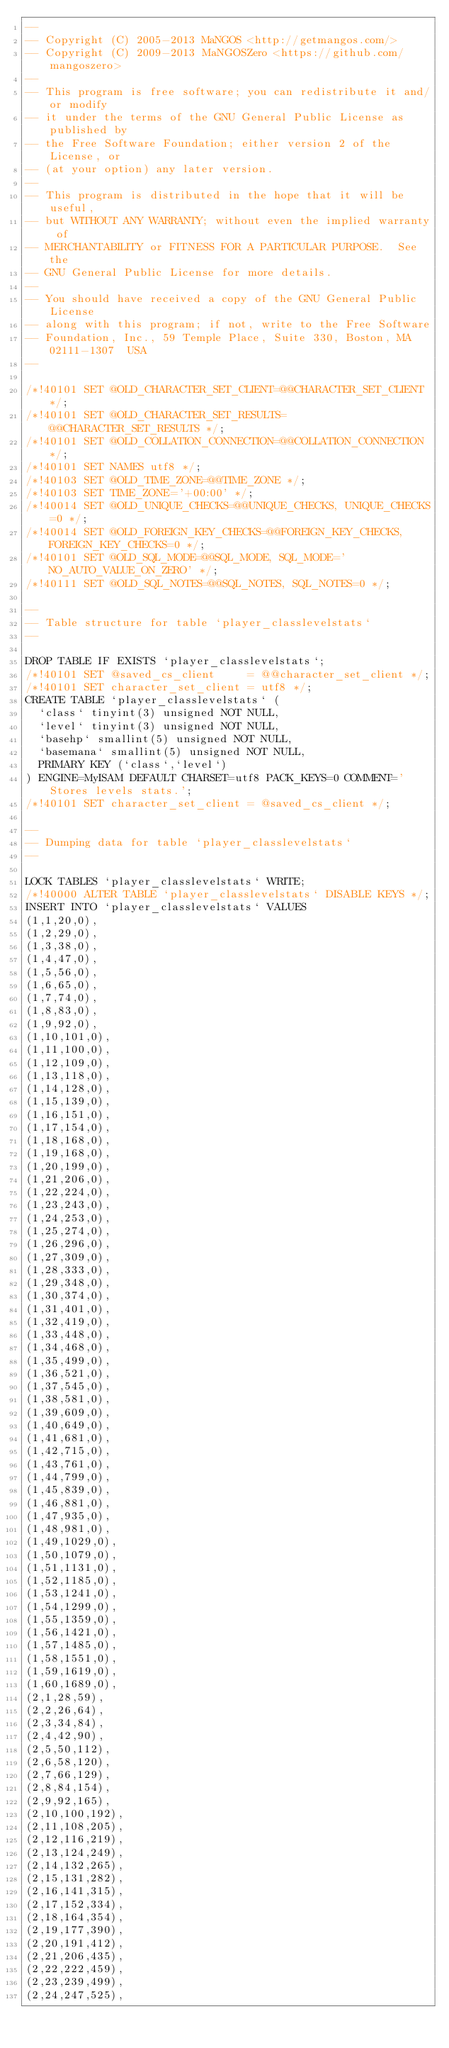Convert code to text. <code><loc_0><loc_0><loc_500><loc_500><_SQL_>--
-- Copyright (C) 2005-2013 MaNGOS <http://getmangos.com/>
-- Copyright (C) 2009-2013 MaNGOSZero <https://github.com/mangoszero>
--
-- This program is free software; you can redistribute it and/or modify
-- it under the terms of the GNU General Public License as published by
-- the Free Software Foundation; either version 2 of the License, or
-- (at your option) any later version.
--
-- This program is distributed in the hope that it will be useful,
-- but WITHOUT ANY WARRANTY; without even the implied warranty of
-- MERCHANTABILITY or FITNESS FOR A PARTICULAR PURPOSE.  See the
-- GNU General Public License for more details.
--
-- You should have received a copy of the GNU General Public License
-- along with this program; if not, write to the Free Software
-- Foundation, Inc., 59 Temple Place, Suite 330, Boston, MA  02111-1307  USA
--

/*!40101 SET @OLD_CHARACTER_SET_CLIENT=@@CHARACTER_SET_CLIENT */;
/*!40101 SET @OLD_CHARACTER_SET_RESULTS=@@CHARACTER_SET_RESULTS */;
/*!40101 SET @OLD_COLLATION_CONNECTION=@@COLLATION_CONNECTION */;
/*!40101 SET NAMES utf8 */;
/*!40103 SET @OLD_TIME_ZONE=@@TIME_ZONE */;
/*!40103 SET TIME_ZONE='+00:00' */;
/*!40014 SET @OLD_UNIQUE_CHECKS=@@UNIQUE_CHECKS, UNIQUE_CHECKS=0 */;
/*!40014 SET @OLD_FOREIGN_KEY_CHECKS=@@FOREIGN_KEY_CHECKS, FOREIGN_KEY_CHECKS=0 */;
/*!40101 SET @OLD_SQL_MODE=@@SQL_MODE, SQL_MODE='NO_AUTO_VALUE_ON_ZERO' */;
/*!40111 SET @OLD_SQL_NOTES=@@SQL_NOTES, SQL_NOTES=0 */;

--
-- Table structure for table `player_classlevelstats`
--

DROP TABLE IF EXISTS `player_classlevelstats`;
/*!40101 SET @saved_cs_client     = @@character_set_client */;
/*!40101 SET character_set_client = utf8 */;
CREATE TABLE `player_classlevelstats` (
  `class` tinyint(3) unsigned NOT NULL,
  `level` tinyint(3) unsigned NOT NULL,
  `basehp` smallint(5) unsigned NOT NULL,
  `basemana` smallint(5) unsigned NOT NULL,
  PRIMARY KEY (`class`,`level`)
) ENGINE=MyISAM DEFAULT CHARSET=utf8 PACK_KEYS=0 COMMENT='Stores levels stats.';
/*!40101 SET character_set_client = @saved_cs_client */;

--
-- Dumping data for table `player_classlevelstats`
--

LOCK TABLES `player_classlevelstats` WRITE;
/*!40000 ALTER TABLE `player_classlevelstats` DISABLE KEYS */;
INSERT INTO `player_classlevelstats` VALUES
(1,1,20,0),
(1,2,29,0),
(1,3,38,0),
(1,4,47,0),
(1,5,56,0),
(1,6,65,0),
(1,7,74,0),
(1,8,83,0),
(1,9,92,0),
(1,10,101,0),
(1,11,100,0),
(1,12,109,0),
(1,13,118,0),
(1,14,128,0),
(1,15,139,0),
(1,16,151,0),
(1,17,154,0),
(1,18,168,0),
(1,19,168,0),
(1,20,199,0),
(1,21,206,0),
(1,22,224,0),
(1,23,243,0),
(1,24,253,0),
(1,25,274,0),
(1,26,296,0),
(1,27,309,0),
(1,28,333,0),
(1,29,348,0),
(1,30,374,0),
(1,31,401,0),
(1,32,419,0),
(1,33,448,0),
(1,34,468,0),
(1,35,499,0),
(1,36,521,0),
(1,37,545,0),
(1,38,581,0),
(1,39,609,0),
(1,40,649,0),
(1,41,681,0),
(1,42,715,0),
(1,43,761,0),
(1,44,799,0),
(1,45,839,0),
(1,46,881,0),
(1,47,935,0),
(1,48,981,0),
(1,49,1029,0),
(1,50,1079,0),
(1,51,1131,0),
(1,52,1185,0),
(1,53,1241,0),
(1,54,1299,0),
(1,55,1359,0),
(1,56,1421,0),
(1,57,1485,0),
(1,58,1551,0),
(1,59,1619,0),
(1,60,1689,0),
(2,1,28,59),
(2,2,26,64),
(2,3,34,84),
(2,4,42,90),
(2,5,50,112),
(2,6,58,120),
(2,7,66,129),
(2,8,84,154),
(2,9,92,165),
(2,10,100,192),
(2,11,108,205),
(2,12,116,219),
(2,13,124,249),
(2,14,132,265),
(2,15,131,282),
(2,16,141,315),
(2,17,152,334),
(2,18,164,354),
(2,19,177,390),
(2,20,191,412),
(2,21,206,435),
(2,22,222,459),
(2,23,239,499),
(2,24,247,525),</code> 